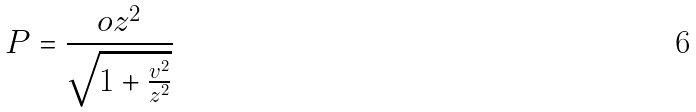<formula> <loc_0><loc_0><loc_500><loc_500>P = \frac { o z ^ { 2 } } { \sqrt { 1 + \frac { v ^ { 2 } } { z ^ { 2 } } } }</formula> 